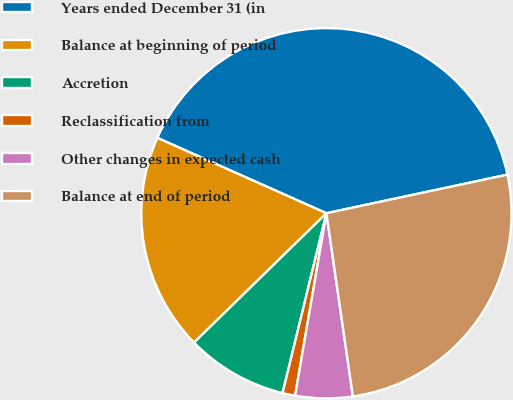<chart> <loc_0><loc_0><loc_500><loc_500><pie_chart><fcel>Years ended December 31 (in<fcel>Balance at beginning of period<fcel>Accretion<fcel>Reclassification from<fcel>Other changes in expected cash<fcel>Balance at end of period<nl><fcel>39.99%<fcel>18.99%<fcel>8.88%<fcel>1.1%<fcel>4.99%<fcel>26.06%<nl></chart> 